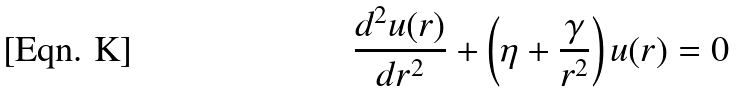<formula> <loc_0><loc_0><loc_500><loc_500>\frac { d ^ { 2 } u ( r ) } { d r ^ { 2 } } + \left ( \eta + \frac { \gamma } { r ^ { 2 } } \right ) u ( r ) = 0 \,</formula> 